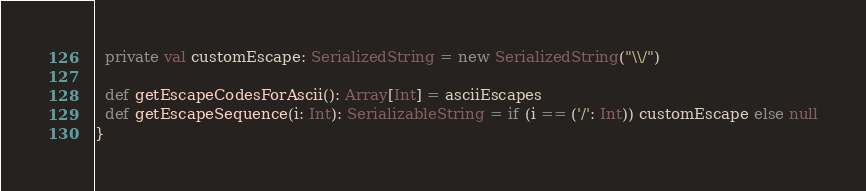Convert code to text. <code><loc_0><loc_0><loc_500><loc_500><_Scala_>  private val customEscape: SerializedString = new SerializedString("\\/")

  def getEscapeCodesForAscii(): Array[Int] = asciiEscapes
  def getEscapeSequence(i: Int): SerializableString = if (i == ('/': Int)) customEscape else null
}</code> 